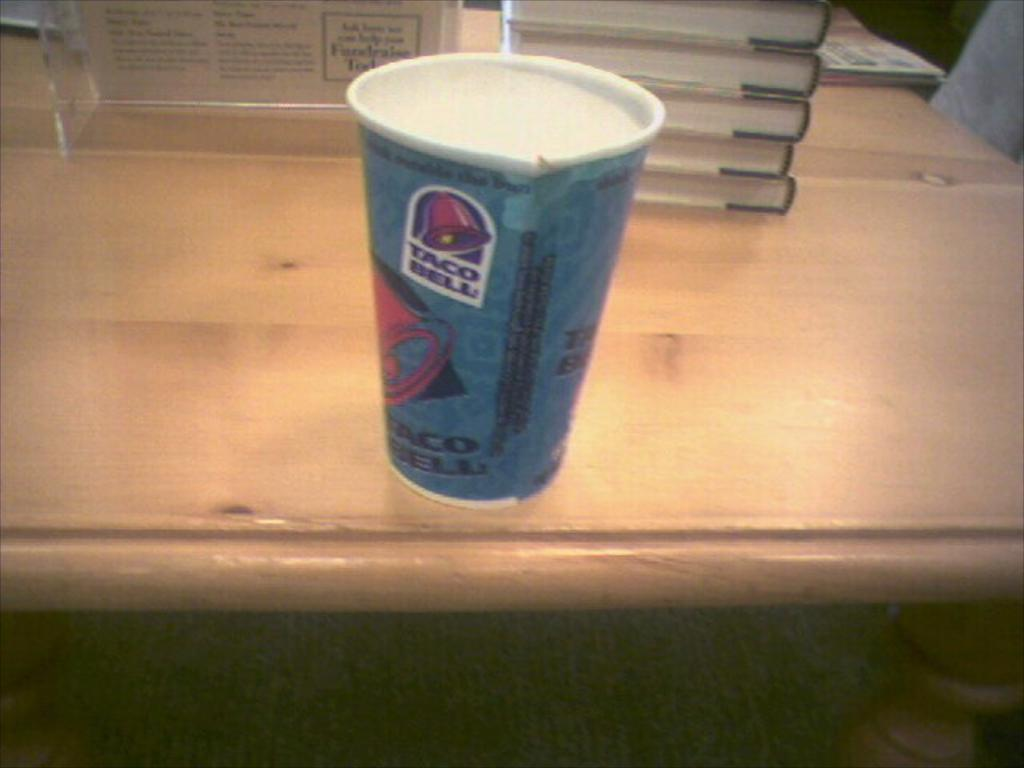What type of furniture is present in the image? There is a table in the image. What items are placed on the table? There are books, a glass, and a board on the table. Can you see any bait on the table in the image? There is no bait present on the table in the image. What type of trees are visible in the image? There are no trees visible in the image; it only shows a table with items on it. 